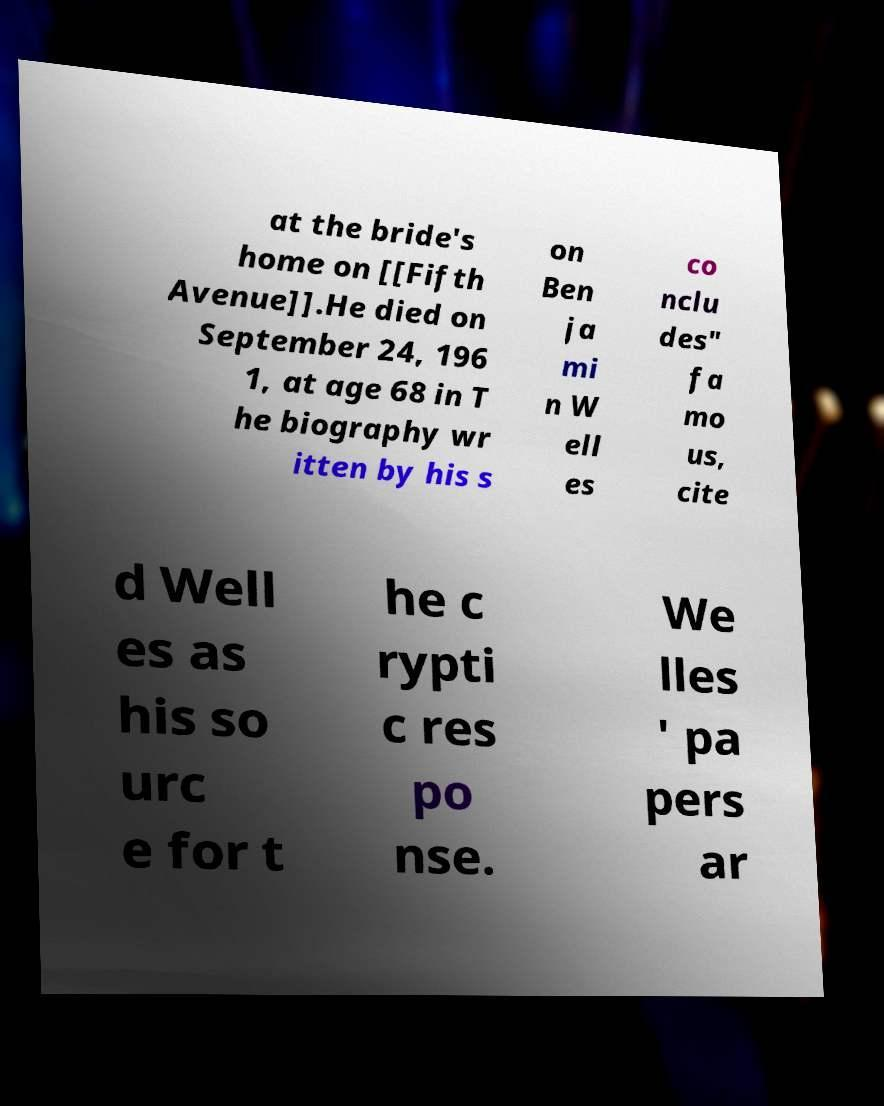Can you read and provide the text displayed in the image?This photo seems to have some interesting text. Can you extract and type it out for me? at the bride's home on [[Fifth Avenue]].He died on September 24, 196 1, at age 68 in T he biography wr itten by his s on Ben ja mi n W ell es co nclu des" fa mo us, cite d Well es as his so urc e for t he c rypti c res po nse. We lles ' pa pers ar 